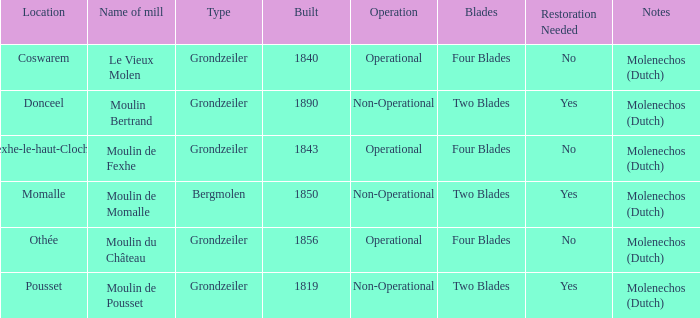What is year Built of the Moulin de Momalle Mill? 1850.0. 